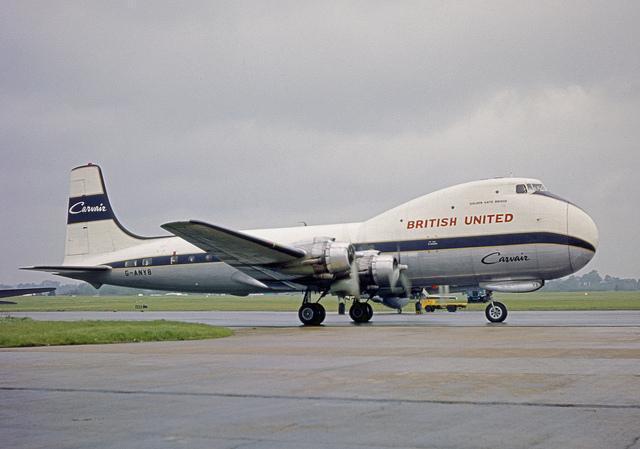How many people are wearing orange?
Give a very brief answer. 0. 